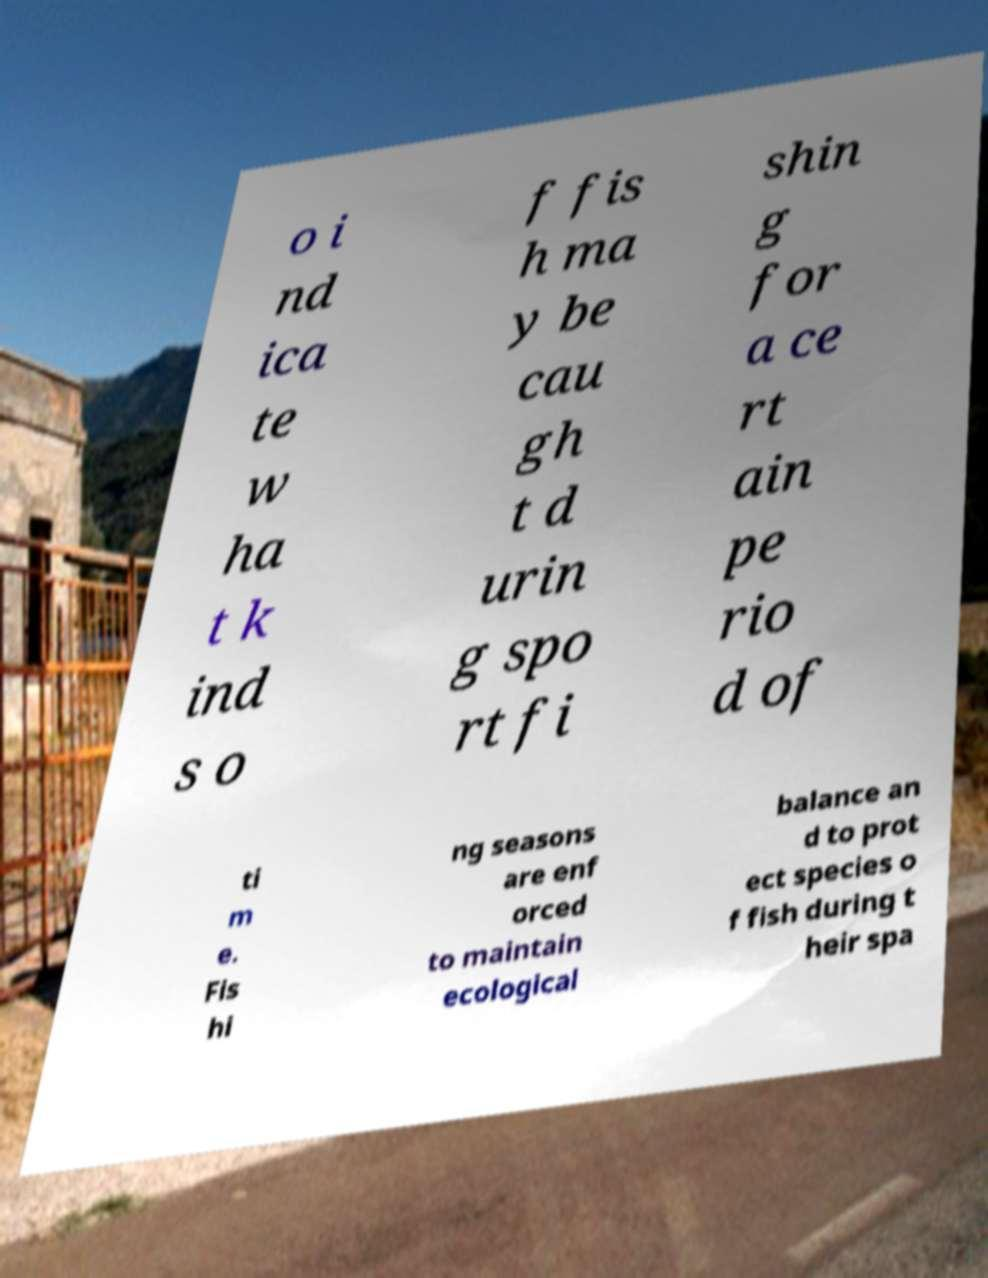I need the written content from this picture converted into text. Can you do that? o i nd ica te w ha t k ind s o f fis h ma y be cau gh t d urin g spo rt fi shin g for a ce rt ain pe rio d of ti m e. Fis hi ng seasons are enf orced to maintain ecological balance an d to prot ect species o f fish during t heir spa 